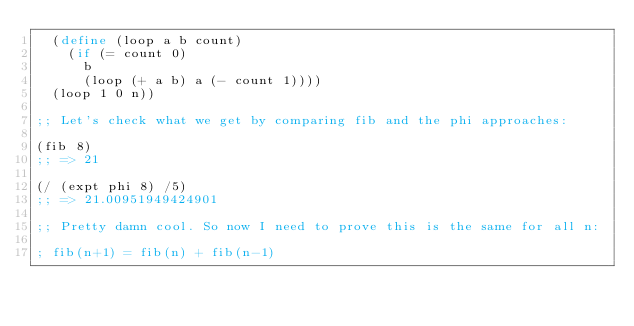Convert code to text. <code><loc_0><loc_0><loc_500><loc_500><_Scheme_>  (define (loop a b count)
    (if (= count 0)
      b
      (loop (+ a b) a (- count 1))))
  (loop 1 0 n))

;; Let's check what we get by comparing fib and the phi approaches:

(fib 8)
;; => 21

(/ (expt phi 8) /5)
;; => 21.00951949424901

;; Pretty damn cool. So now I need to prove this is the same for all n:

; fib(n+1) = fib(n) + fib(n-1)
</code> 